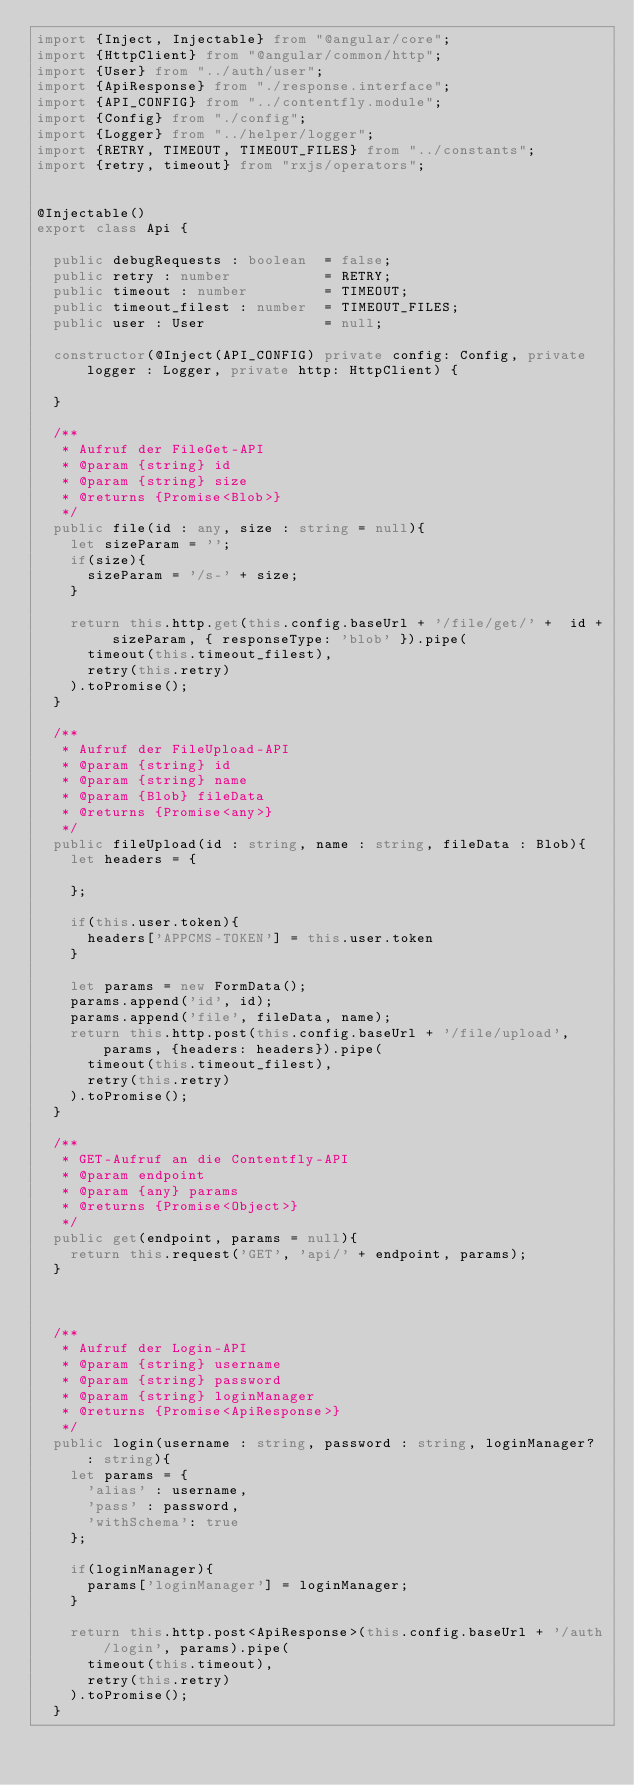<code> <loc_0><loc_0><loc_500><loc_500><_TypeScript_>import {Inject, Injectable} from "@angular/core";
import {HttpClient} from "@angular/common/http";
import {User} from "../auth/user";
import {ApiResponse} from "./response.interface";
import {API_CONFIG} from "../contentfly.module";
import {Config} from "./config";
import {Logger} from "../helper/logger";
import {RETRY, TIMEOUT, TIMEOUT_FILES} from "../constants";
import {retry, timeout} from "rxjs/operators";


@Injectable()
export class Api {

  public debugRequests : boolean  = false;
  public retry : number           = RETRY;
  public timeout : number         = TIMEOUT;
  public timeout_filest : number  = TIMEOUT_FILES;
  public user : User              = null;

  constructor(@Inject(API_CONFIG) private config: Config, private logger : Logger, private http: HttpClient) {

  }

  /**
   * Aufruf der FileGet-API
   * @param {string} id
   * @param {string} size
   * @returns {Promise<Blob>}
   */
  public file(id : any, size : string = null){
    let sizeParam = '';
    if(size){
      sizeParam = '/s-' + size;
    }

    return this.http.get(this.config.baseUrl + '/file/get/' +  id + sizeParam, { responseType: 'blob' }).pipe(
      timeout(this.timeout_filest),
      retry(this.retry)
    ).toPromise();
  }

  /**
   * Aufruf der FileUpload-API
   * @param {string} id
   * @param {string} name
   * @param {Blob} fileData
   * @returns {Promise<any>}
   */
  public fileUpload(id : string, name : string, fileData : Blob){
    let headers = {

    };

    if(this.user.token){
      headers['APPCMS-TOKEN'] = this.user.token
    }

    let params = new FormData();
    params.append('id', id);
    params.append('file', fileData, name);
    return this.http.post(this.config.baseUrl + '/file/upload', params, {headers: headers}).pipe(
      timeout(this.timeout_filest),
      retry(this.retry)
    ).toPromise();
  }

  /**
   * GET-Aufruf an die Contentfly-API
   * @param endpoint
   * @param {any} params
   * @returns {Promise<Object>}
   */
  public get(endpoint, params = null){
    return this.request('GET', 'api/' + endpoint, params);
  }



  /**
   * Aufruf der Login-API
   * @param {string} username
   * @param {string} password
   * @param {string} loginManager
   * @returns {Promise<ApiResponse>}
   */
  public login(username : string, password : string, loginManager? : string){
    let params = {
      'alias' : username,
      'pass' : password,
      'withSchema': true
    };

    if(loginManager){
      params['loginManager'] = loginManager;
    }

    return this.http.post<ApiResponse>(this.config.baseUrl + '/auth/login', params).pipe(
      timeout(this.timeout),
      retry(this.retry)
    ).toPromise();
  }
</code> 